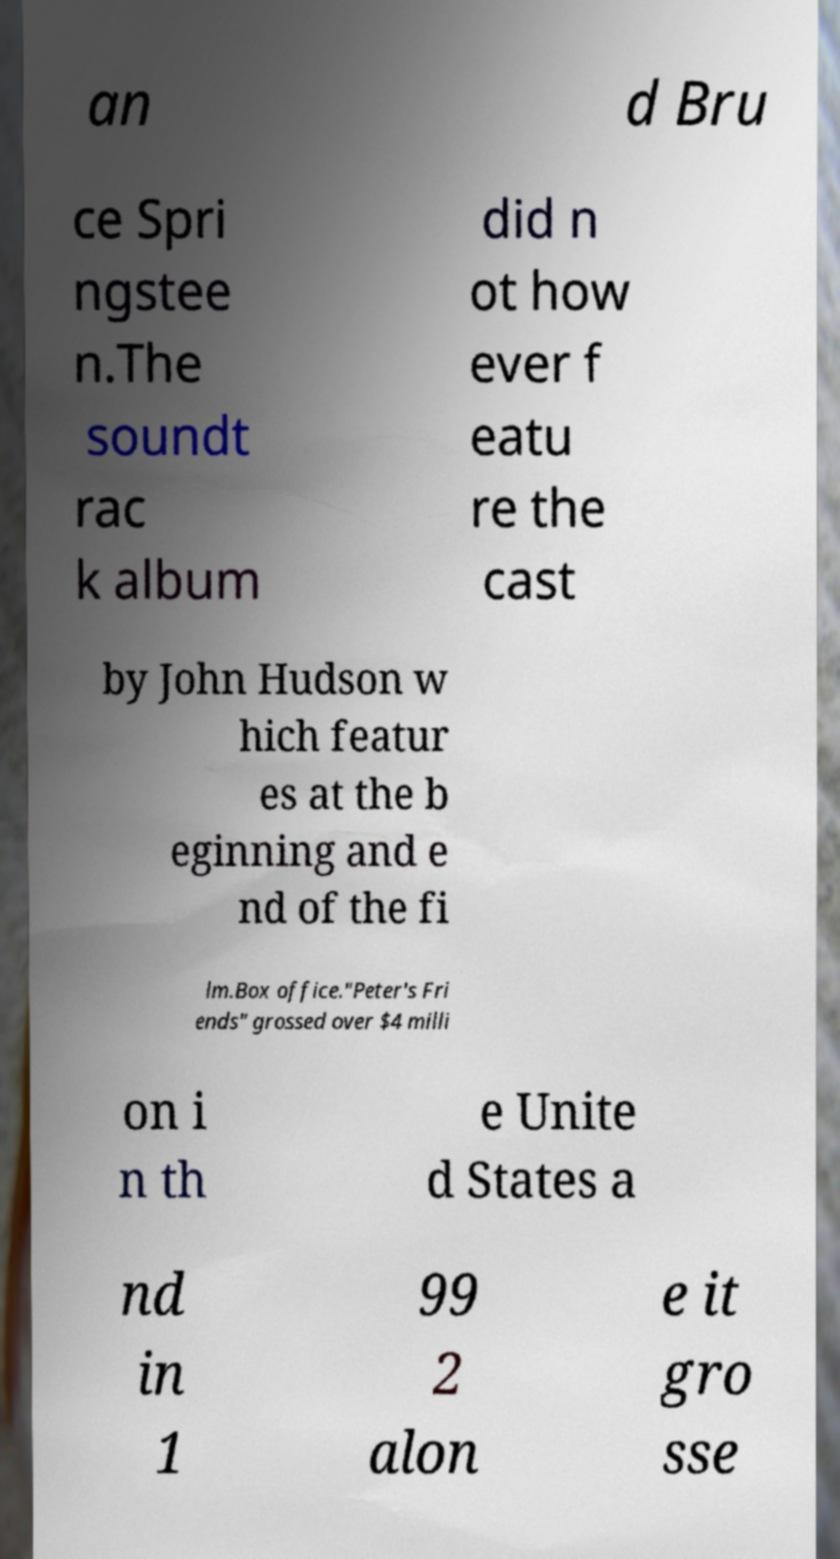Can you accurately transcribe the text from the provided image for me? an d Bru ce Spri ngstee n.The soundt rac k album did n ot how ever f eatu re the cast by John Hudson w hich featur es at the b eginning and e nd of the fi lm.Box office."Peter's Fri ends" grossed over $4 milli on i n th e Unite d States a nd in 1 99 2 alon e it gro sse 